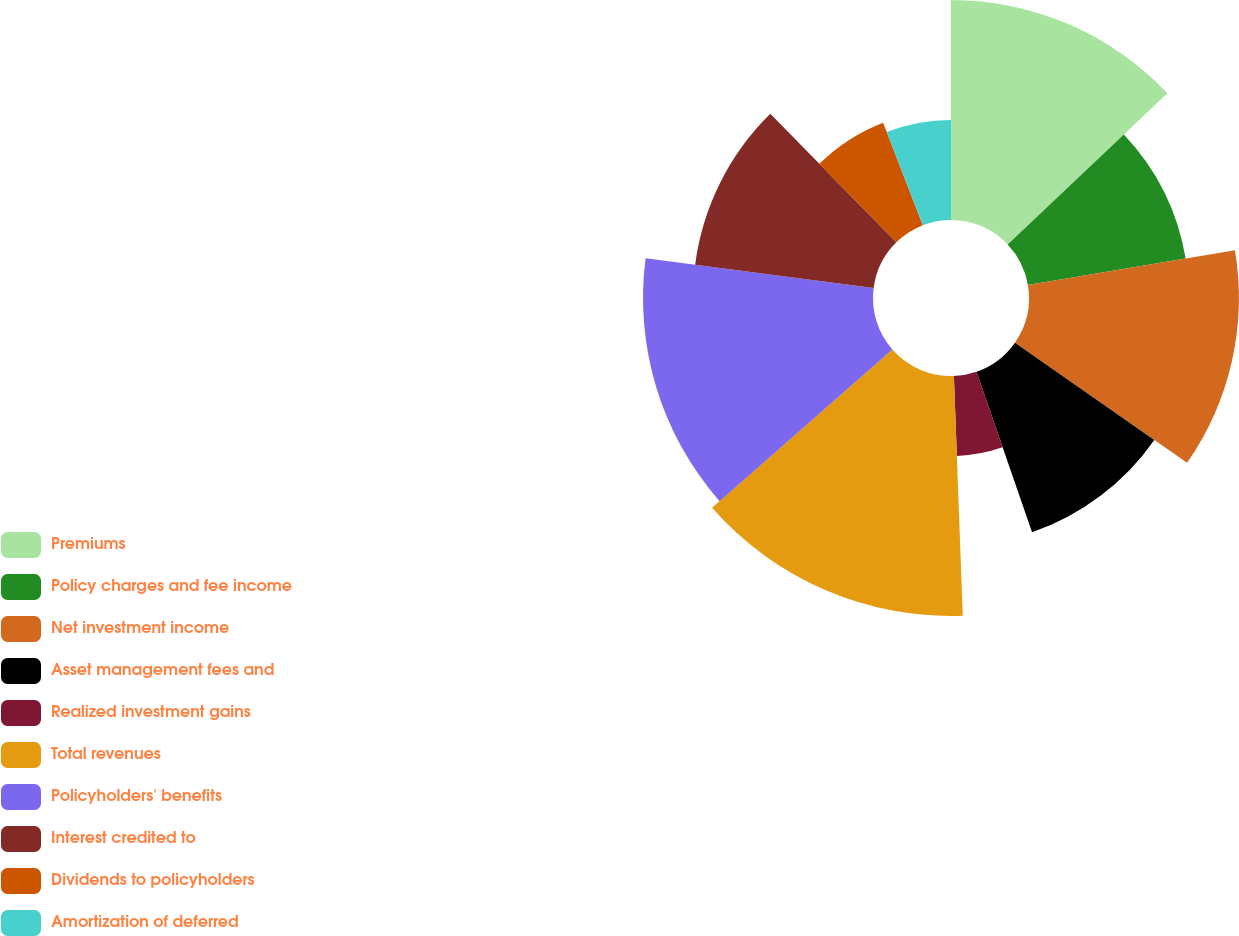<chart> <loc_0><loc_0><loc_500><loc_500><pie_chart><fcel>Premiums<fcel>Policy charges and fee income<fcel>Net investment income<fcel>Asset management fees and<fcel>Realized investment gains<fcel>Total revenues<fcel>Policyholders' benefits<fcel>Interest credited to<fcel>Dividends to policyholders<fcel>Amortization of deferred<nl><fcel>12.94%<fcel>9.41%<fcel>12.35%<fcel>10.0%<fcel>4.71%<fcel>14.12%<fcel>13.53%<fcel>10.59%<fcel>6.47%<fcel>5.88%<nl></chart> 